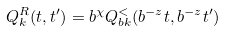Convert formula to latex. <formula><loc_0><loc_0><loc_500><loc_500>Q _ { k } ^ { R } ( t , t ^ { \prime } ) = b ^ { \chi } Q _ { b k } ^ { < } ( b ^ { - z } t , b ^ { - z } t ^ { \prime } )</formula> 